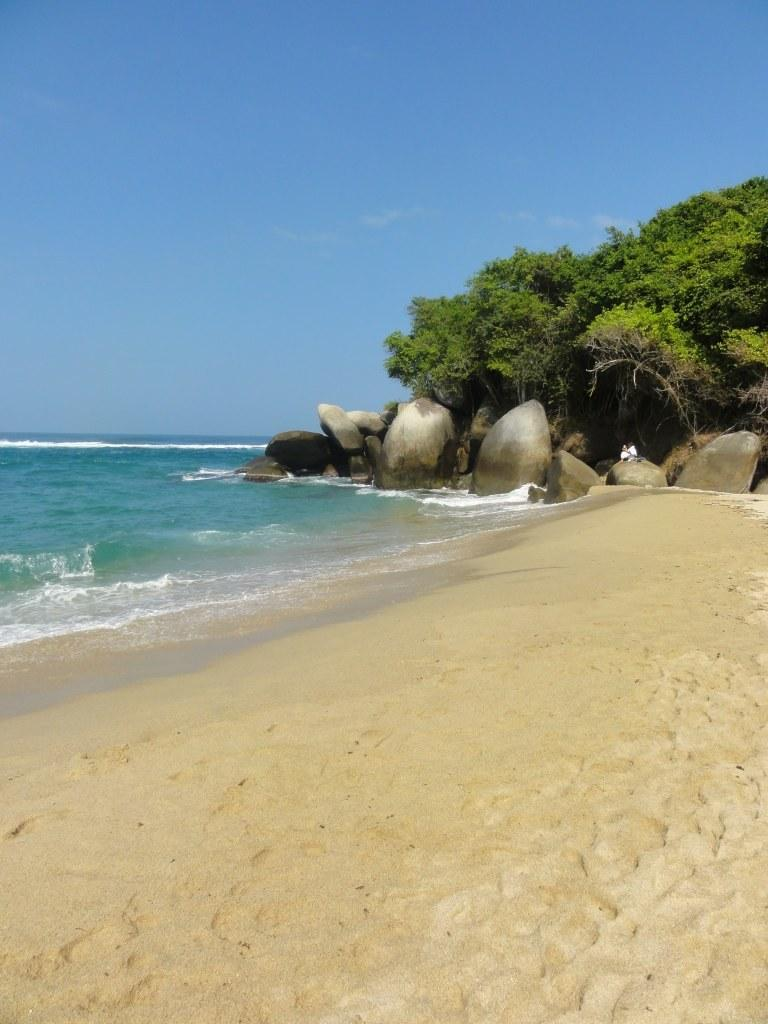What type of location is depicted in the picture? There is a beach in the picture. What is a characteristic feature of the beach? There is sand on the beach. What body of water is visible in the picture? There is an ocean in the picture. What type of vegetation can be seen in the picture? There are trees in the picture. What is the condition of the sky in the picture? The sky is clear in the picture. Can you tell me how many pictures of tramps are hanging on the trees in the image? There are no pictures of tramps present in the image; it features a beach with an ocean, sand, trees, and a clear sky. How many flies can be seen flying over the ocean in the image? There are no flies visible in the image; it only shows a beach, sand, trees, and a clear sky. 